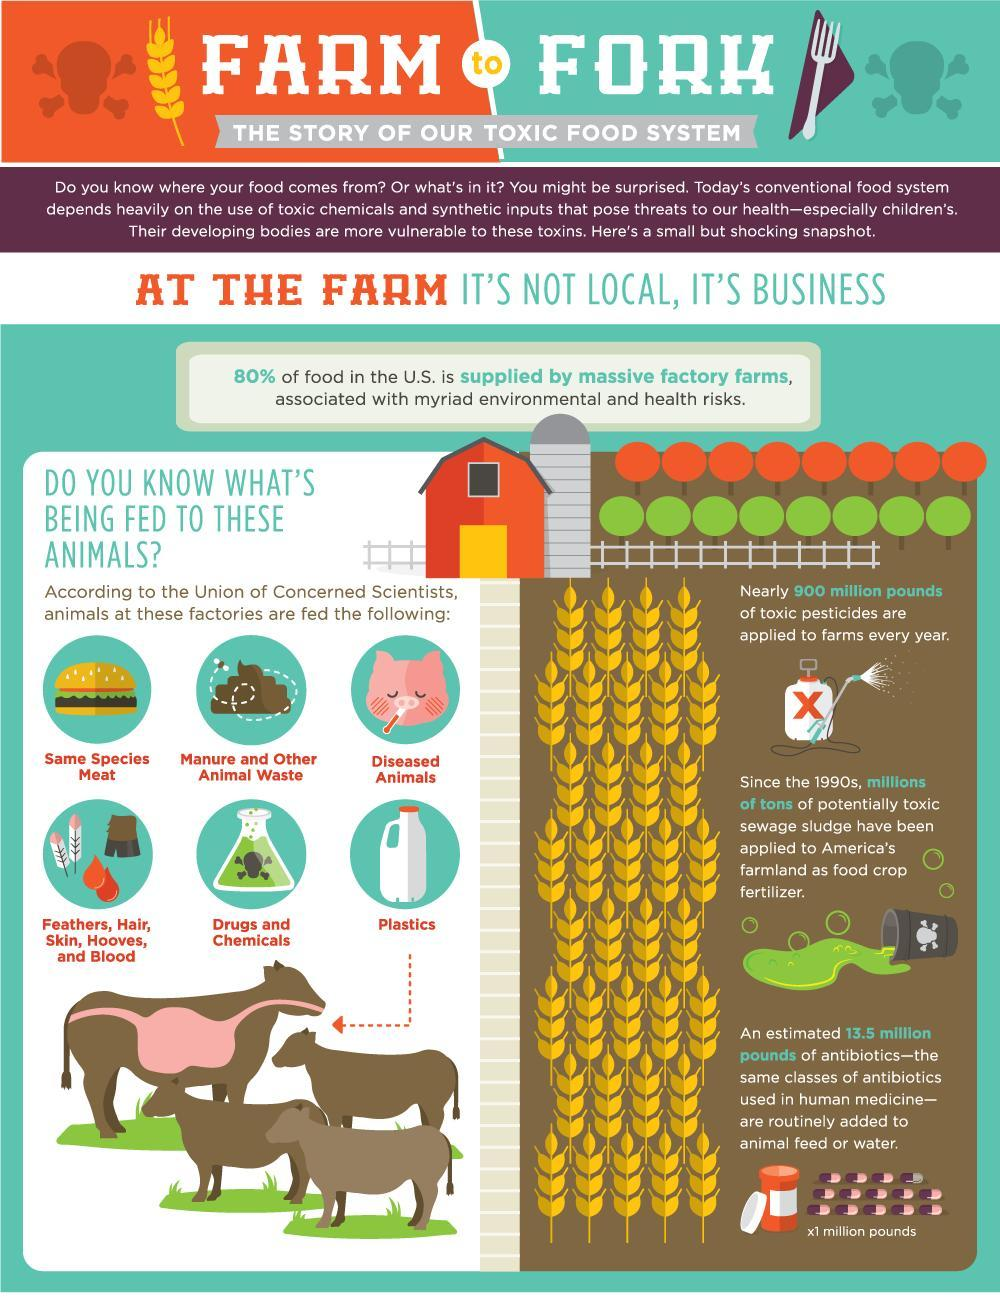How many types of high risk feed are given to the farm animals?
Answer the question with a short phrase. 6 